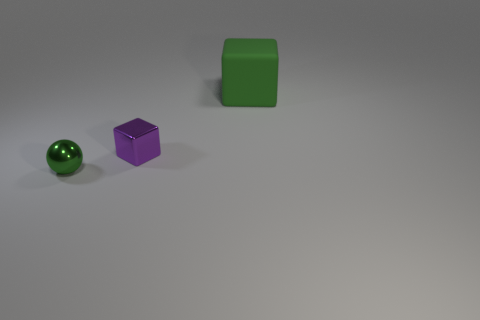Add 1 shiny things. How many objects exist? 4 Subtract all balls. How many objects are left? 2 Add 2 shiny cubes. How many shiny cubes exist? 3 Subtract 0 yellow cylinders. How many objects are left? 3 Subtract all small things. Subtract all tiny green shiny objects. How many objects are left? 0 Add 1 small purple metallic objects. How many small purple metallic objects are left? 2 